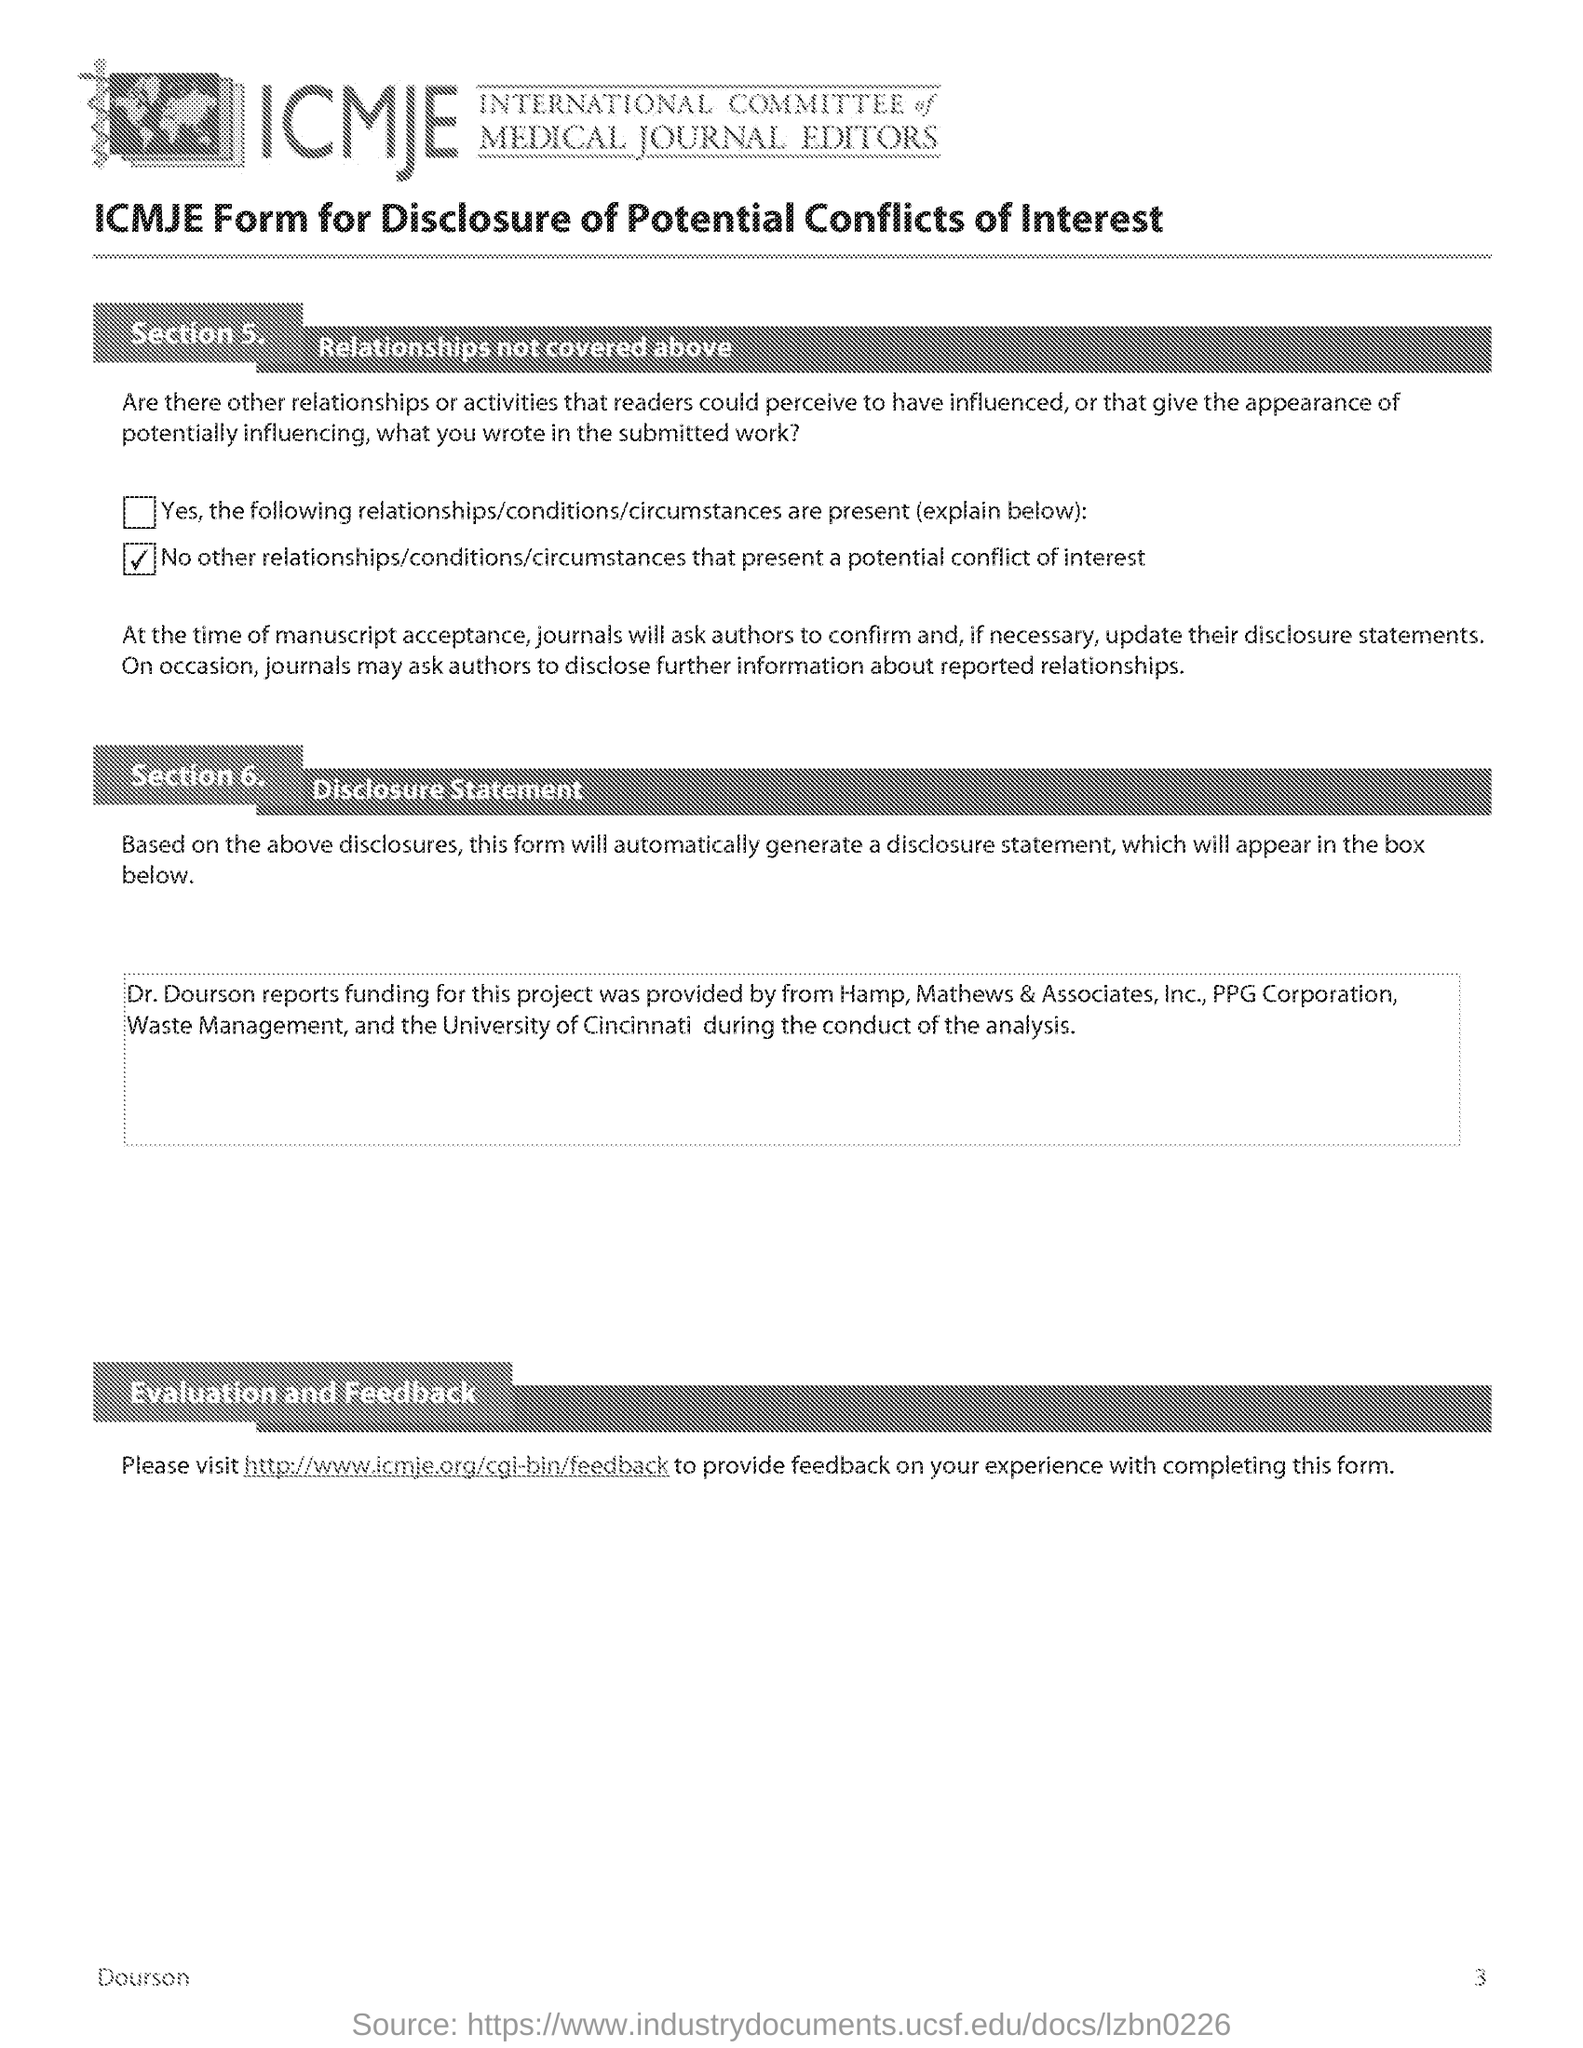What does ICMJE stand for?
Your answer should be very brief. International Committee of Medical Journal Editors. What is Section 5 ?
Provide a succinct answer. Relationships not covered above. What is Section 6?
Offer a terse response. Disclosure Statement. 